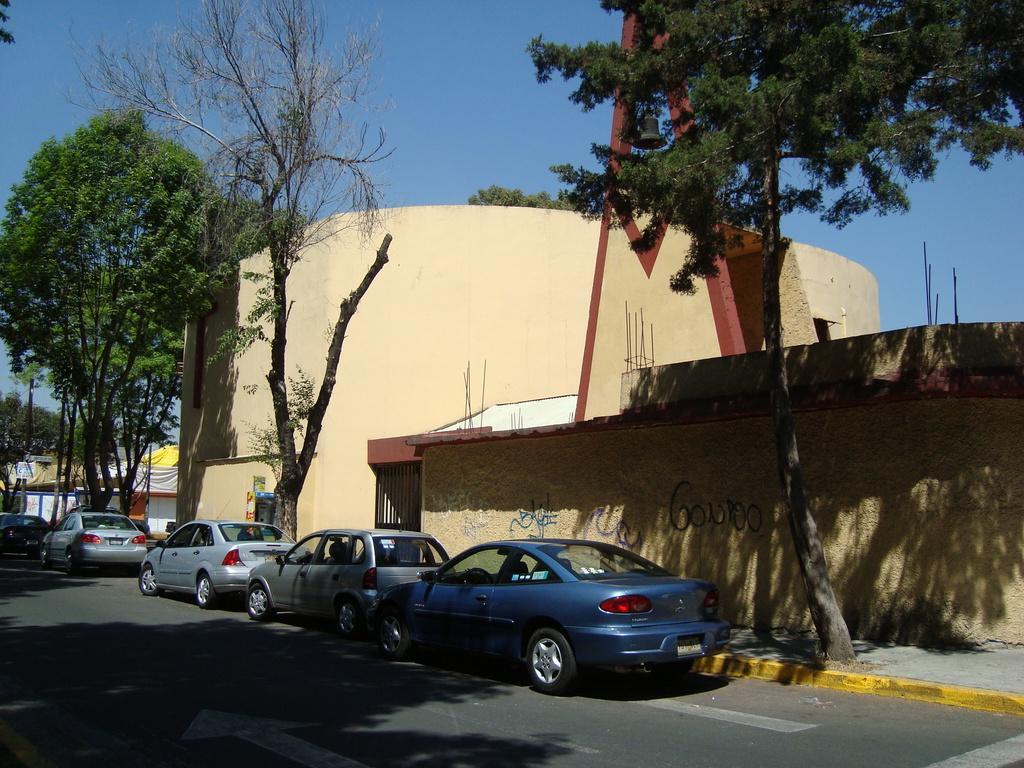Can you describe this image briefly? In this picture we can see cars on the road, building, trees, rods, some objects and in the background we can see the sky. 